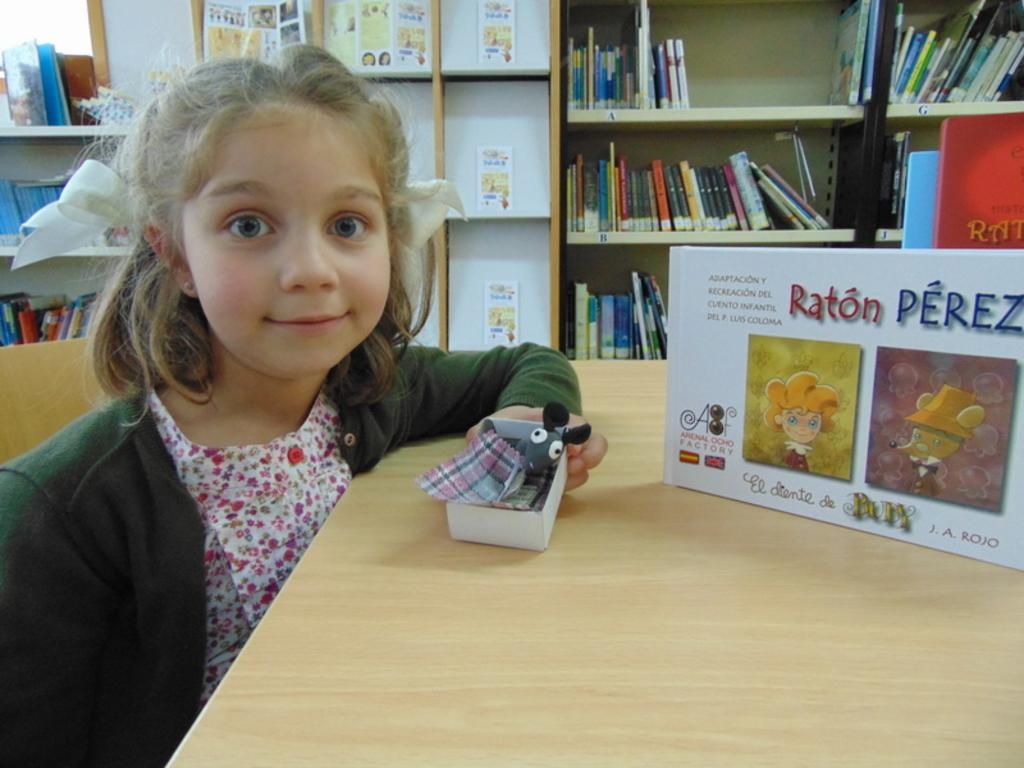Provide a one-sentence caption for the provided image. A girl sits in front of a box that says "Raton PEREZ" and is holding a toy mouse in a box. 